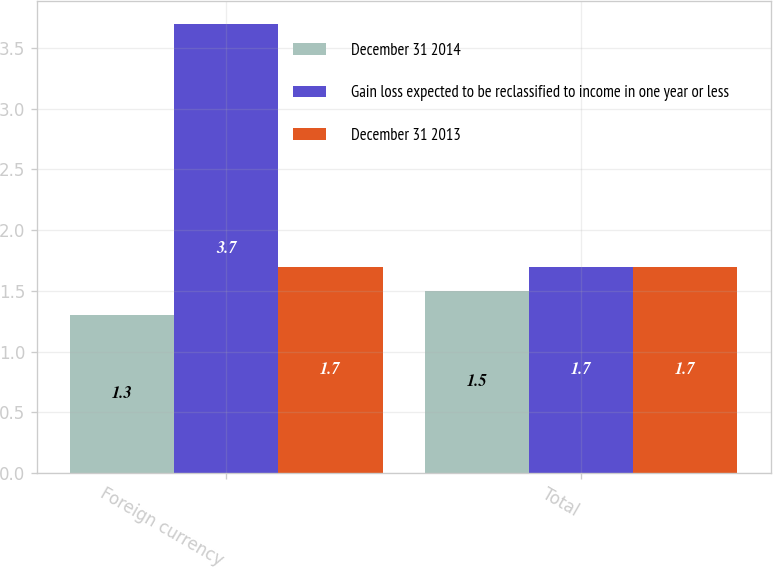<chart> <loc_0><loc_0><loc_500><loc_500><stacked_bar_chart><ecel><fcel>Foreign currency<fcel>Total<nl><fcel>December 31 2014<fcel>1.3<fcel>1.5<nl><fcel>Gain loss expected to be reclassified to income in one year or less<fcel>3.7<fcel>1.7<nl><fcel>December 31 2013<fcel>1.7<fcel>1.7<nl></chart> 